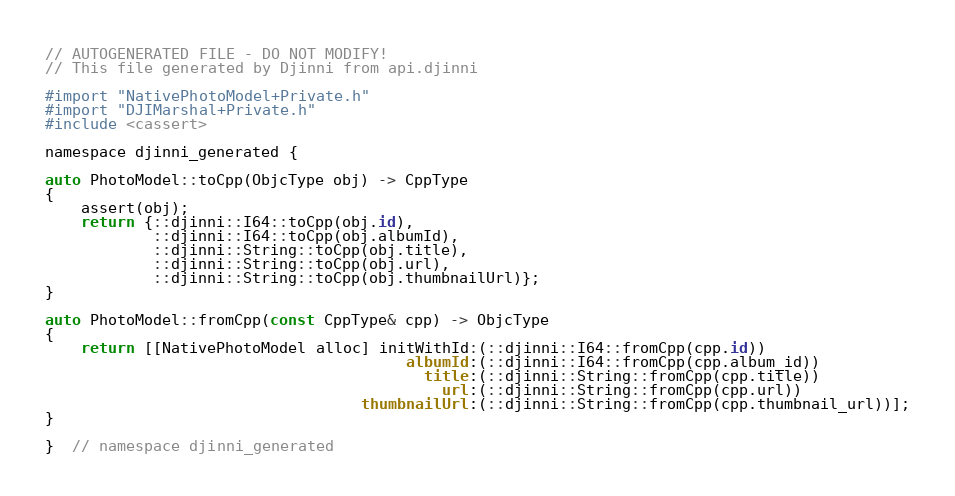<code> <loc_0><loc_0><loc_500><loc_500><_ObjectiveC_>// AUTOGENERATED FILE - DO NOT MODIFY!
// This file generated by Djinni from api.djinni

#import "NativePhotoModel+Private.h"
#import "DJIMarshal+Private.h"
#include <cassert>

namespace djinni_generated {

auto PhotoModel::toCpp(ObjcType obj) -> CppType
{
    assert(obj);
    return {::djinni::I64::toCpp(obj.id),
            ::djinni::I64::toCpp(obj.albumId),
            ::djinni::String::toCpp(obj.title),
            ::djinni::String::toCpp(obj.url),
            ::djinni::String::toCpp(obj.thumbnailUrl)};
}

auto PhotoModel::fromCpp(const CppType& cpp) -> ObjcType
{
    return [[NativePhotoModel alloc] initWithId:(::djinni::I64::fromCpp(cpp.id))
                                        albumId:(::djinni::I64::fromCpp(cpp.album_id))
                                          title:(::djinni::String::fromCpp(cpp.title))
                                            url:(::djinni::String::fromCpp(cpp.url))
                                   thumbnailUrl:(::djinni::String::fromCpp(cpp.thumbnail_url))];
}

}  // namespace djinni_generated
</code> 